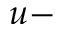Convert formula to latex. <formula><loc_0><loc_0><loc_500><loc_500>u -</formula> 